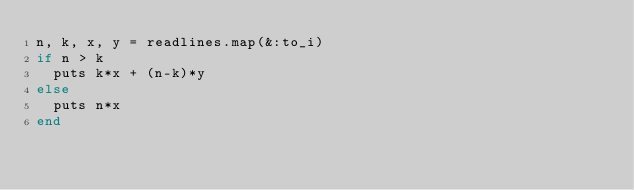Convert code to text. <code><loc_0><loc_0><loc_500><loc_500><_Ruby_>n, k, x, y = readlines.map(&:to_i)
if n > k
  puts k*x + (n-k)*y
else
  puts n*x
end</code> 